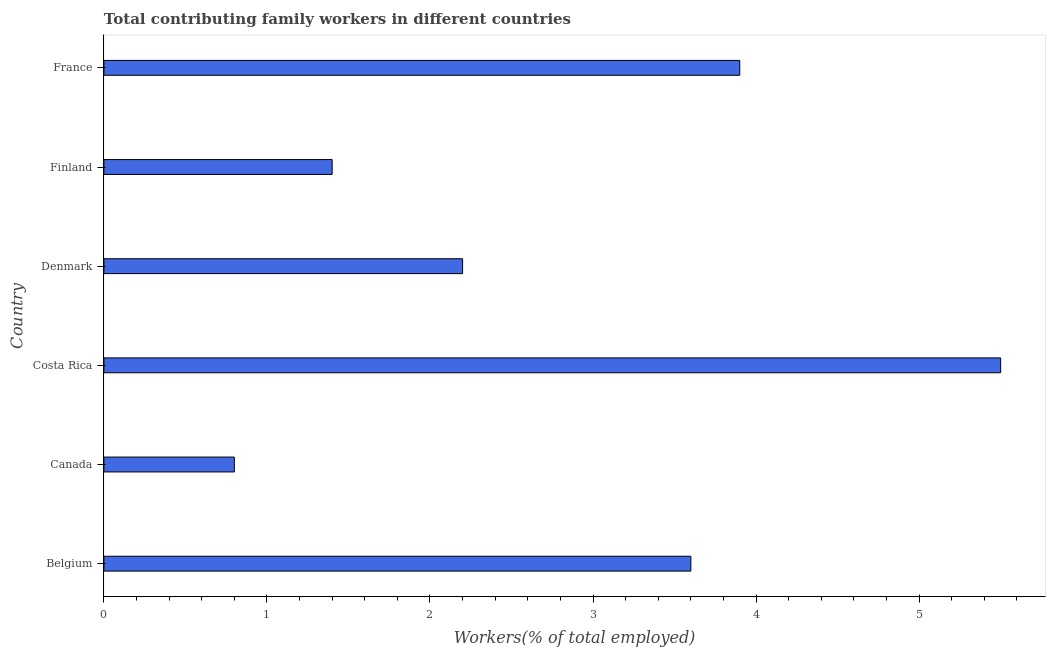Does the graph contain any zero values?
Keep it short and to the point. No. Does the graph contain grids?
Your response must be concise. No. What is the title of the graph?
Provide a short and direct response. Total contributing family workers in different countries. What is the label or title of the X-axis?
Keep it short and to the point. Workers(% of total employed). What is the contributing family workers in Denmark?
Your response must be concise. 2.2. Across all countries, what is the minimum contributing family workers?
Your response must be concise. 0.8. In which country was the contributing family workers maximum?
Your answer should be compact. Costa Rica. In which country was the contributing family workers minimum?
Ensure brevity in your answer.  Canada. What is the sum of the contributing family workers?
Offer a very short reply. 17.4. What is the difference between the contributing family workers in Costa Rica and Denmark?
Your answer should be compact. 3.3. What is the median contributing family workers?
Your response must be concise. 2.9. What is the ratio of the contributing family workers in Costa Rica to that in France?
Your response must be concise. 1.41. Is the contributing family workers in Canada less than that in France?
Your response must be concise. Yes. Is the difference between the contributing family workers in Belgium and Finland greater than the difference between any two countries?
Provide a short and direct response. No. What is the difference between the highest and the second highest contributing family workers?
Keep it short and to the point. 1.6. Is the sum of the contributing family workers in Belgium and Denmark greater than the maximum contributing family workers across all countries?
Keep it short and to the point. Yes. What is the difference between the highest and the lowest contributing family workers?
Offer a terse response. 4.7. In how many countries, is the contributing family workers greater than the average contributing family workers taken over all countries?
Ensure brevity in your answer.  3. Are all the bars in the graph horizontal?
Your answer should be compact. Yes. How many countries are there in the graph?
Ensure brevity in your answer.  6. What is the Workers(% of total employed) of Belgium?
Your answer should be compact. 3.6. What is the Workers(% of total employed) of Canada?
Ensure brevity in your answer.  0.8. What is the Workers(% of total employed) of Denmark?
Your answer should be very brief. 2.2. What is the Workers(% of total employed) of Finland?
Offer a terse response. 1.4. What is the Workers(% of total employed) in France?
Your answer should be very brief. 3.9. What is the difference between the Workers(% of total employed) in Belgium and France?
Keep it short and to the point. -0.3. What is the difference between the Workers(% of total employed) in Canada and Costa Rica?
Keep it short and to the point. -4.7. What is the difference between the Workers(% of total employed) in Costa Rica and France?
Provide a succinct answer. 1.6. What is the ratio of the Workers(% of total employed) in Belgium to that in Costa Rica?
Offer a terse response. 0.66. What is the ratio of the Workers(% of total employed) in Belgium to that in Denmark?
Give a very brief answer. 1.64. What is the ratio of the Workers(% of total employed) in Belgium to that in Finland?
Your answer should be very brief. 2.57. What is the ratio of the Workers(% of total employed) in Belgium to that in France?
Provide a succinct answer. 0.92. What is the ratio of the Workers(% of total employed) in Canada to that in Costa Rica?
Your answer should be compact. 0.14. What is the ratio of the Workers(% of total employed) in Canada to that in Denmark?
Give a very brief answer. 0.36. What is the ratio of the Workers(% of total employed) in Canada to that in Finland?
Provide a short and direct response. 0.57. What is the ratio of the Workers(% of total employed) in Canada to that in France?
Your answer should be very brief. 0.2. What is the ratio of the Workers(% of total employed) in Costa Rica to that in Finland?
Give a very brief answer. 3.93. What is the ratio of the Workers(% of total employed) in Costa Rica to that in France?
Your response must be concise. 1.41. What is the ratio of the Workers(% of total employed) in Denmark to that in Finland?
Your answer should be very brief. 1.57. What is the ratio of the Workers(% of total employed) in Denmark to that in France?
Your response must be concise. 0.56. What is the ratio of the Workers(% of total employed) in Finland to that in France?
Your answer should be compact. 0.36. 